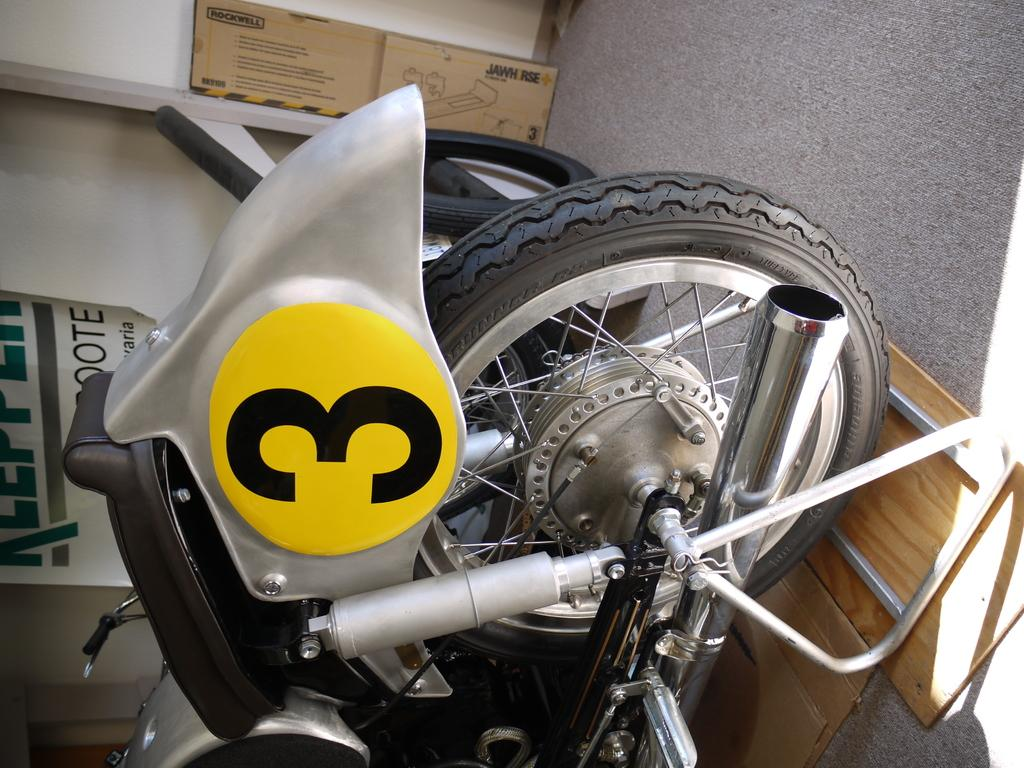<image>
Share a concise interpretation of the image provided. Type of motorcycle with the number three sticker on the back 